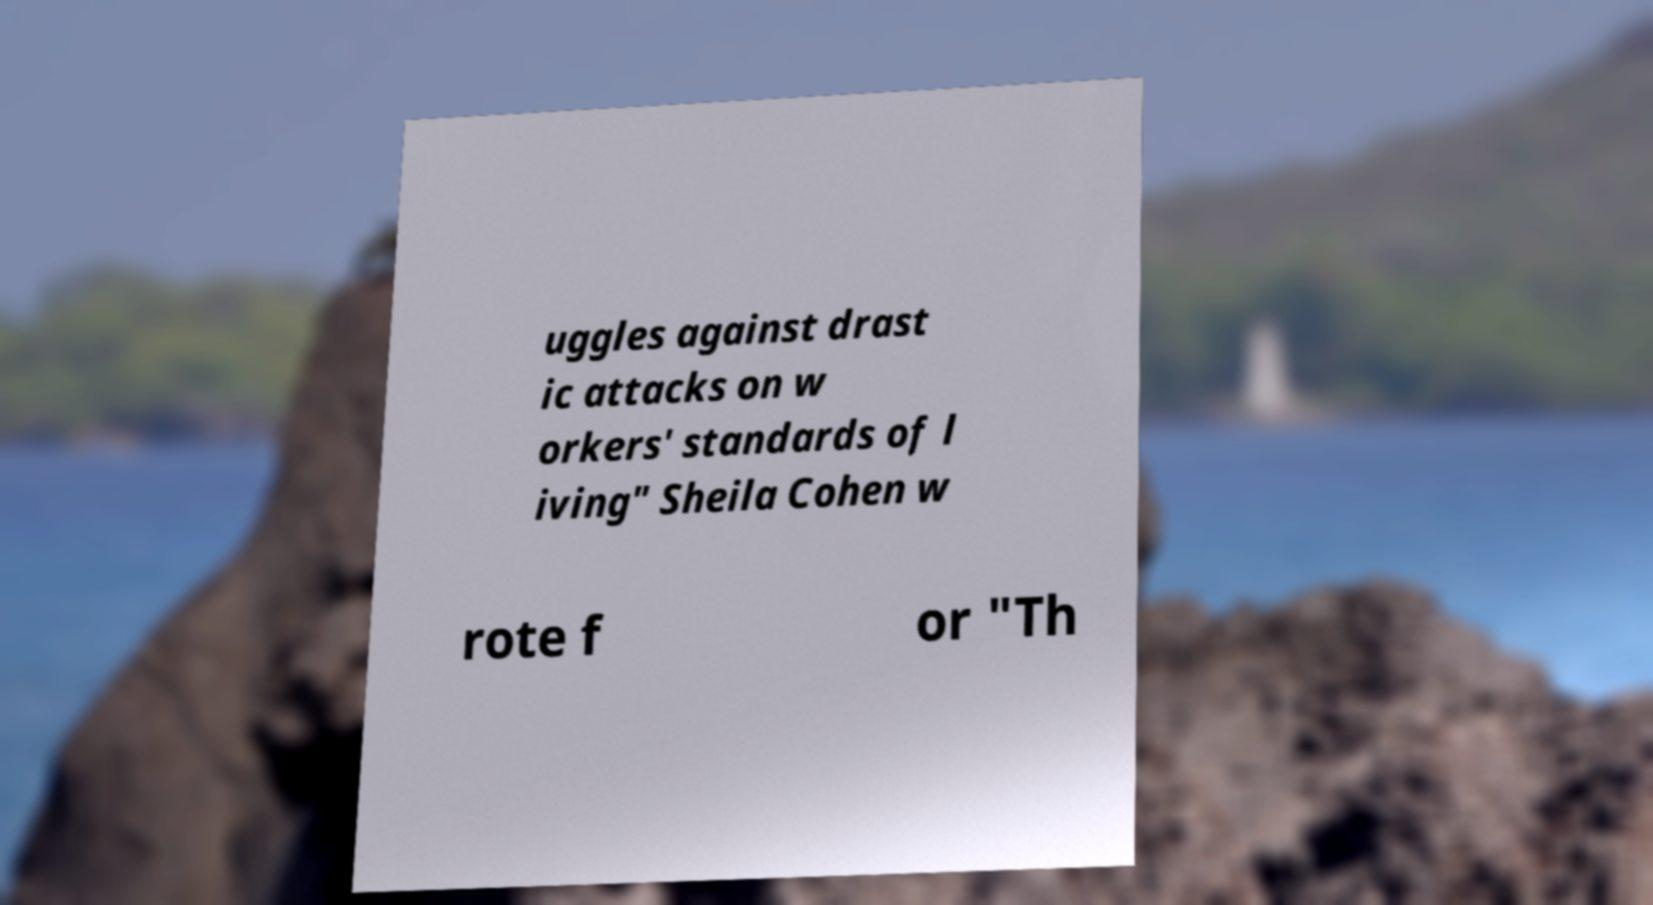Can you accurately transcribe the text from the provided image for me? uggles against drast ic attacks on w orkers' standards of l iving" Sheila Cohen w rote f or "Th 